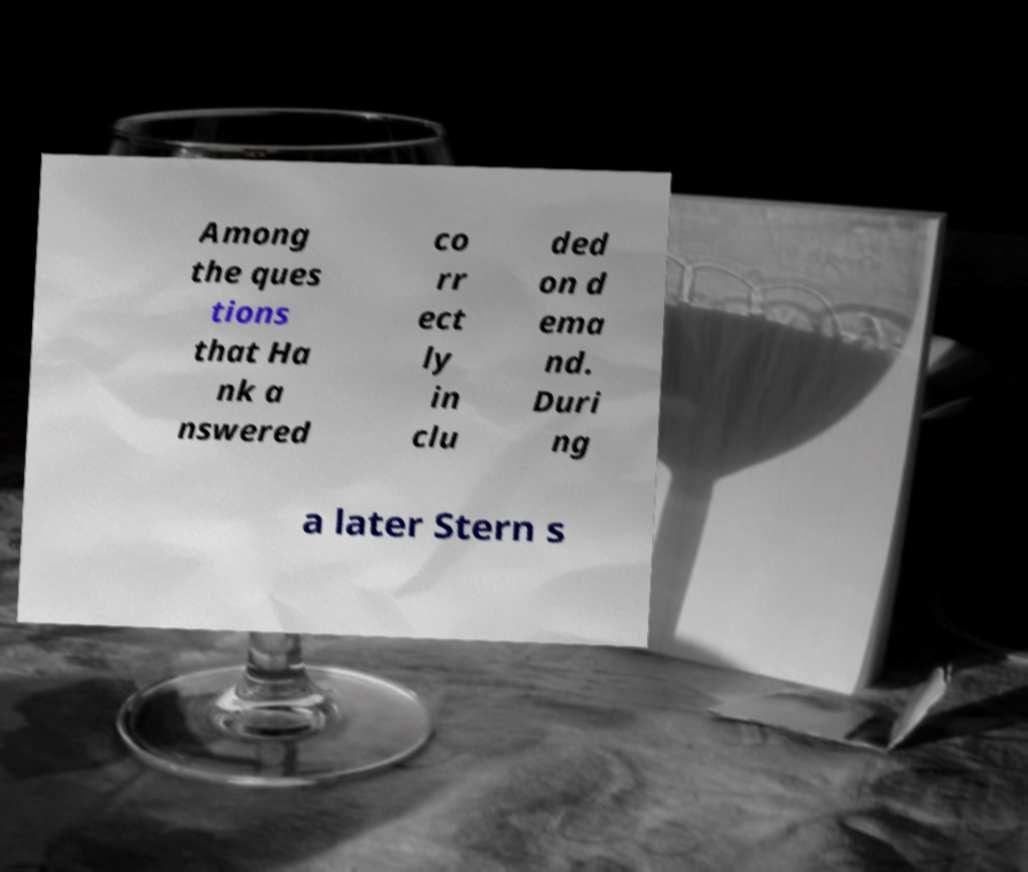Can you read and provide the text displayed in the image?This photo seems to have some interesting text. Can you extract and type it out for me? Among the ques tions that Ha nk a nswered co rr ect ly in clu ded on d ema nd. Duri ng a later Stern s 